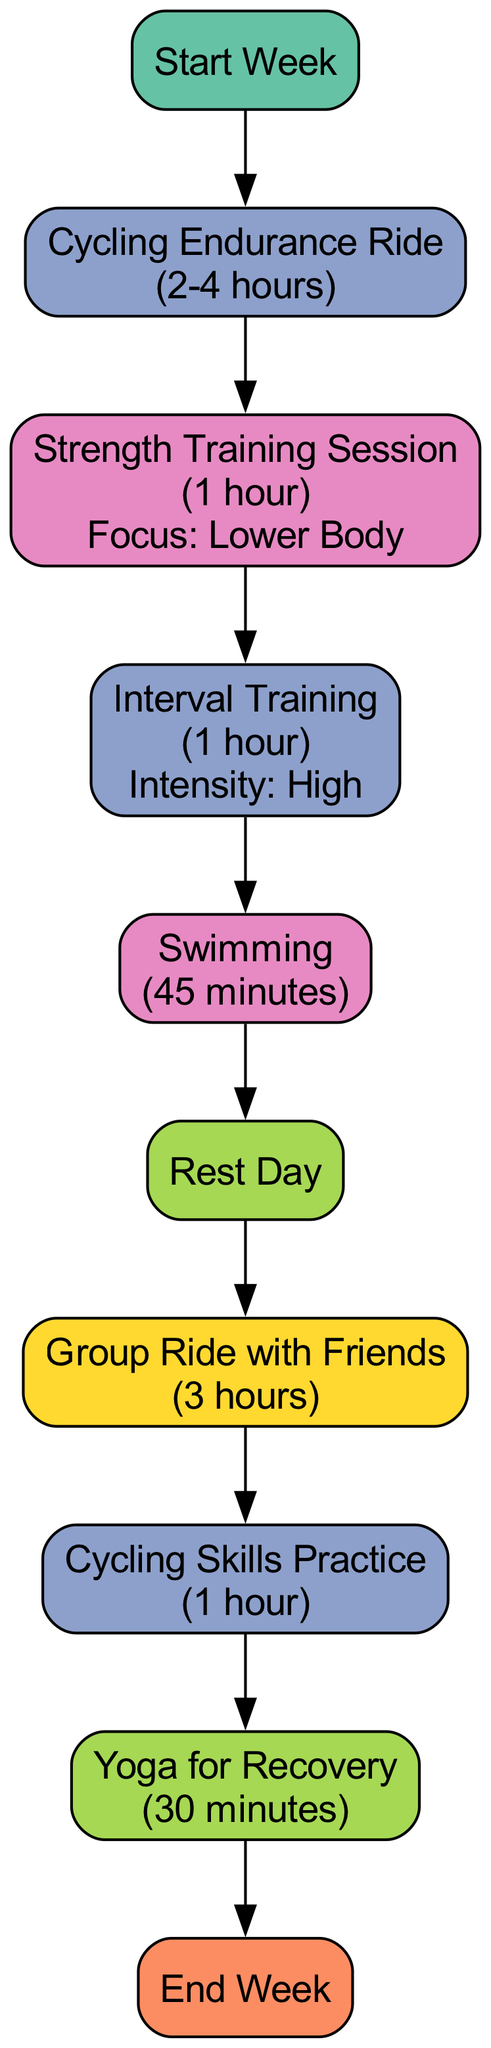What is the first activity in the flowchart? The flowchart starts with the "Start Week" node. This is always the initial point before any activities begin, indicating the start of the training plan.
Answer: Start Week How long is the Cycling Endurance Ride? The Cycling Endurance Ride is indicated to have a duration of "2-4 hours". This detail is specified directly in the corresponding node.
Answer: 2-4 hours What type of workout follows the Rest Day? After the Rest Day, the next activity is the "Group Ride with Friends", which is categorized as a social workout. This indicates that social engagements follow recovery time.
Answer: Group Ride with Friends How many strength training sessions are included in the flowchart? The flowchart features only one strength training session, which is specifically listed as a cross-training activity.
Answer: One Which activity has a focus on lower body strength? The "Strength Training Session" specifically notes a focus on lower body, making it the activity aimed at developing strength in that area.
Answer: Strength Training Session What is the total number of nodes in this flowchart? The flowchart has a total of 10 nodes, representing various activities and markers, including the start and end points of the weekly plan.
Answer: 10 How many cross-training activities are listed in the diagram? There are two cross-training activities present in the flowchart: "Strength Training Session" and "Swimming". These activities are distinct from regular cycling workouts.
Answer: Two What is the duration of Yoga for Recovery? The Yoga for Recovery activity has a duration of "30 minutes", as stated in the corresponding node.
Answer: 30 minutes What type of training is Interval Training classified as? Interval Training is classified as a Workout, and its intensity is specified as high, emphasizing its rigorous nature within the training plan.
Answer: Workout 